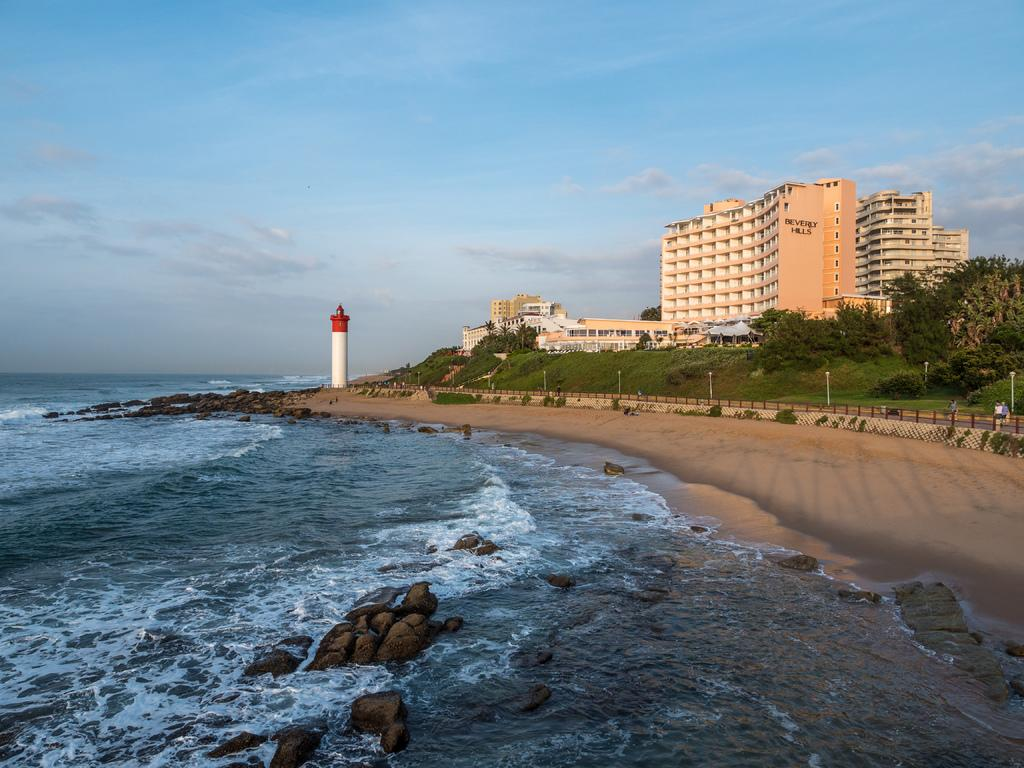What type of surface is visible in the image? There is a water surface in the image. What other type of surface is near the water? There is a surface with mud near the water. What type of vegetation can be seen in the image? There are plants and trees visible in the image. What type of structures are present in the image? There are buildings in the image. What part of the natural environment is visible in the image? The sky is visible in the image, and clouds are present in the sky. What type of crime is being committed near the water in the image? There is no indication of any crime being committed in the image. How does the knee of the person near the water look like in the image? There is no person visible in the image, so it is not possible to describe the appearance of their knee. 